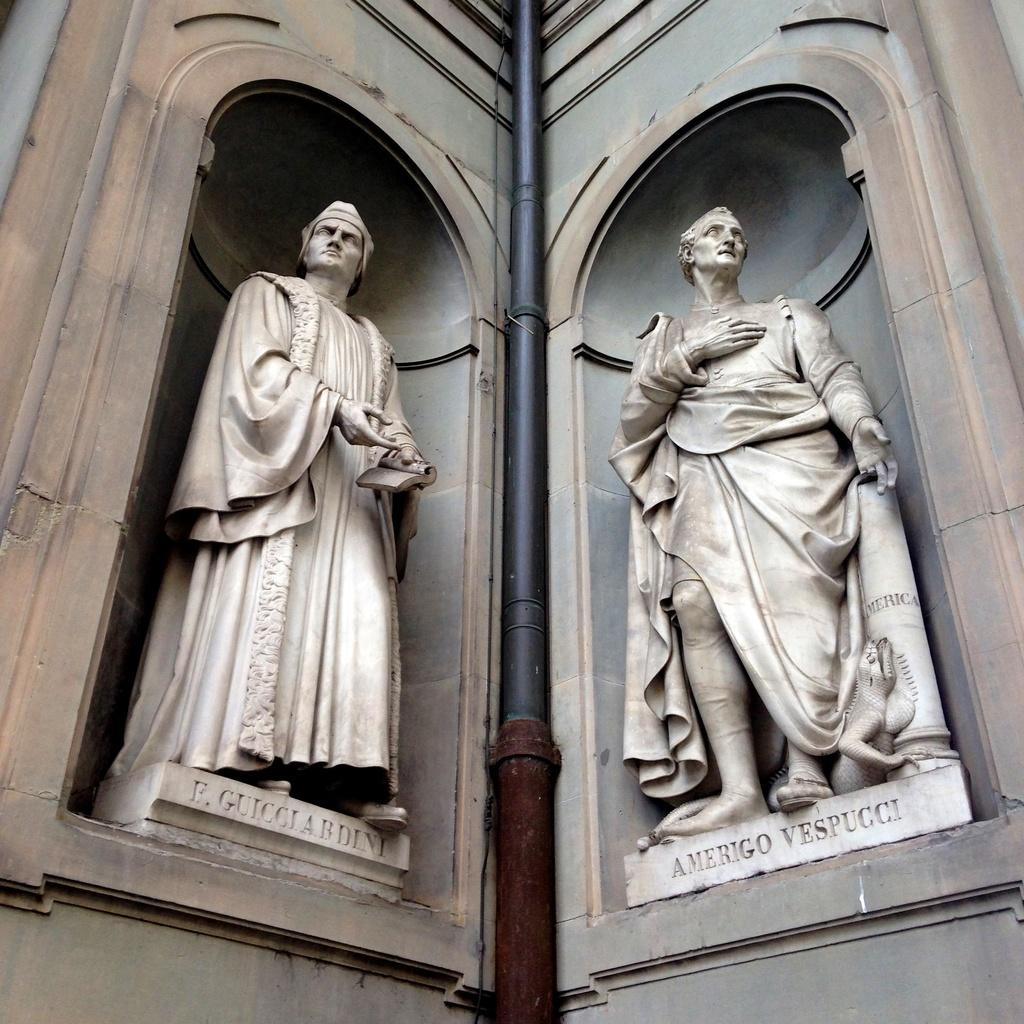What can be seen in the image that represents people? There are sculptures of two people in the image. Are the names of the people mentioned in the image? Yes, the names of the people are mentioned below their respective sculptures. What is present between the two sculptures? There is a black pole between the two sculptures. What type of list can be seen hanging on the arm of one of the sculptures? There is no list present in the image, nor is there any mention of an arm on the sculptures. 